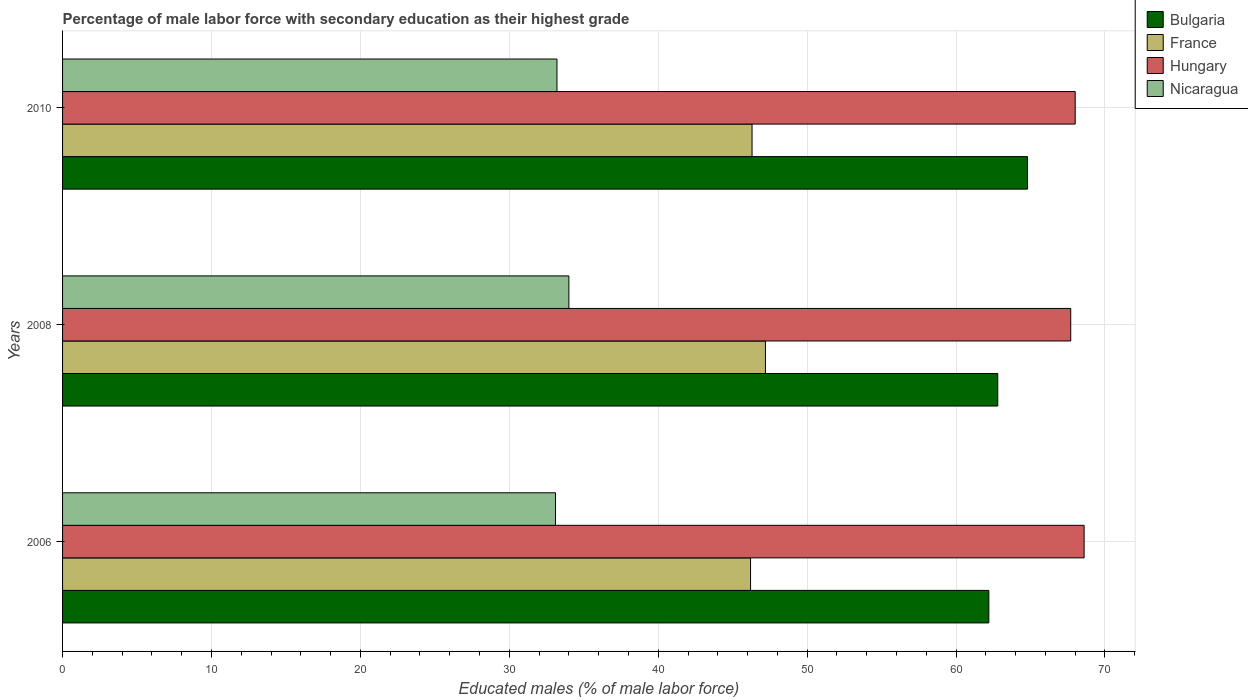Are the number of bars per tick equal to the number of legend labels?
Provide a short and direct response. Yes. Are the number of bars on each tick of the Y-axis equal?
Keep it short and to the point. Yes. How many bars are there on the 2nd tick from the bottom?
Offer a very short reply. 4. What is the percentage of male labor force with secondary education in Nicaragua in 2006?
Ensure brevity in your answer.  33.1. Across all years, what is the maximum percentage of male labor force with secondary education in Hungary?
Make the answer very short. 68.6. Across all years, what is the minimum percentage of male labor force with secondary education in France?
Your response must be concise. 46.2. In which year was the percentage of male labor force with secondary education in Hungary minimum?
Offer a terse response. 2008. What is the total percentage of male labor force with secondary education in Hungary in the graph?
Ensure brevity in your answer.  204.3. What is the difference between the percentage of male labor force with secondary education in Bulgaria in 2006 and that in 2010?
Your answer should be compact. -2.6. What is the difference between the percentage of male labor force with secondary education in France in 2006 and the percentage of male labor force with secondary education in Bulgaria in 2008?
Ensure brevity in your answer.  -16.6. What is the average percentage of male labor force with secondary education in France per year?
Your answer should be compact. 46.57. In the year 2006, what is the difference between the percentage of male labor force with secondary education in Hungary and percentage of male labor force with secondary education in Nicaragua?
Your answer should be very brief. 35.5. In how many years, is the percentage of male labor force with secondary education in Nicaragua greater than 24 %?
Provide a succinct answer. 3. What is the ratio of the percentage of male labor force with secondary education in Nicaragua in 2006 to that in 2008?
Provide a short and direct response. 0.97. Is the percentage of male labor force with secondary education in Bulgaria in 2008 less than that in 2010?
Provide a short and direct response. Yes. What is the difference between the highest and the second highest percentage of male labor force with secondary education in Nicaragua?
Keep it short and to the point. 0.8. What does the 1st bar from the top in 2008 represents?
Your answer should be very brief. Nicaragua. What does the 3rd bar from the bottom in 2006 represents?
Provide a succinct answer. Hungary. How many bars are there?
Make the answer very short. 12. Are all the bars in the graph horizontal?
Provide a short and direct response. Yes. What is the title of the graph?
Keep it short and to the point. Percentage of male labor force with secondary education as their highest grade. What is the label or title of the X-axis?
Ensure brevity in your answer.  Educated males (% of male labor force). What is the Educated males (% of male labor force) in Bulgaria in 2006?
Your answer should be compact. 62.2. What is the Educated males (% of male labor force) of France in 2006?
Your response must be concise. 46.2. What is the Educated males (% of male labor force) in Hungary in 2006?
Provide a succinct answer. 68.6. What is the Educated males (% of male labor force) of Nicaragua in 2006?
Offer a very short reply. 33.1. What is the Educated males (% of male labor force) in Bulgaria in 2008?
Your response must be concise. 62.8. What is the Educated males (% of male labor force) in France in 2008?
Offer a very short reply. 47.2. What is the Educated males (% of male labor force) of Hungary in 2008?
Your answer should be very brief. 67.7. What is the Educated males (% of male labor force) in Bulgaria in 2010?
Your answer should be compact. 64.8. What is the Educated males (% of male labor force) of France in 2010?
Your answer should be compact. 46.3. What is the Educated males (% of male labor force) in Nicaragua in 2010?
Your answer should be compact. 33.2. Across all years, what is the maximum Educated males (% of male labor force) in Bulgaria?
Offer a very short reply. 64.8. Across all years, what is the maximum Educated males (% of male labor force) of France?
Provide a succinct answer. 47.2. Across all years, what is the maximum Educated males (% of male labor force) of Hungary?
Provide a succinct answer. 68.6. Across all years, what is the minimum Educated males (% of male labor force) in Bulgaria?
Provide a short and direct response. 62.2. Across all years, what is the minimum Educated males (% of male labor force) of France?
Your answer should be compact. 46.2. Across all years, what is the minimum Educated males (% of male labor force) in Hungary?
Provide a succinct answer. 67.7. Across all years, what is the minimum Educated males (% of male labor force) in Nicaragua?
Give a very brief answer. 33.1. What is the total Educated males (% of male labor force) of Bulgaria in the graph?
Provide a succinct answer. 189.8. What is the total Educated males (% of male labor force) in France in the graph?
Your response must be concise. 139.7. What is the total Educated males (% of male labor force) in Hungary in the graph?
Keep it short and to the point. 204.3. What is the total Educated males (% of male labor force) of Nicaragua in the graph?
Keep it short and to the point. 100.3. What is the difference between the Educated males (% of male labor force) in Bulgaria in 2006 and that in 2008?
Ensure brevity in your answer.  -0.6. What is the difference between the Educated males (% of male labor force) in France in 2006 and that in 2008?
Provide a succinct answer. -1. What is the difference between the Educated males (% of male labor force) of Nicaragua in 2006 and that in 2008?
Offer a very short reply. -0.9. What is the difference between the Educated males (% of male labor force) in France in 2006 and that in 2010?
Provide a short and direct response. -0.1. What is the difference between the Educated males (% of male labor force) of Hungary in 2006 and that in 2010?
Offer a terse response. 0.6. What is the difference between the Educated males (% of male labor force) of France in 2008 and that in 2010?
Provide a succinct answer. 0.9. What is the difference between the Educated males (% of male labor force) in Hungary in 2008 and that in 2010?
Your answer should be compact. -0.3. What is the difference between the Educated males (% of male labor force) of Nicaragua in 2008 and that in 2010?
Ensure brevity in your answer.  0.8. What is the difference between the Educated males (% of male labor force) in Bulgaria in 2006 and the Educated males (% of male labor force) in France in 2008?
Provide a succinct answer. 15. What is the difference between the Educated males (% of male labor force) in Bulgaria in 2006 and the Educated males (% of male labor force) in Nicaragua in 2008?
Make the answer very short. 28.2. What is the difference between the Educated males (% of male labor force) of France in 2006 and the Educated males (% of male labor force) of Hungary in 2008?
Keep it short and to the point. -21.5. What is the difference between the Educated males (% of male labor force) of Hungary in 2006 and the Educated males (% of male labor force) of Nicaragua in 2008?
Provide a short and direct response. 34.6. What is the difference between the Educated males (% of male labor force) of France in 2006 and the Educated males (% of male labor force) of Hungary in 2010?
Your response must be concise. -21.8. What is the difference between the Educated males (% of male labor force) of France in 2006 and the Educated males (% of male labor force) of Nicaragua in 2010?
Your answer should be compact. 13. What is the difference between the Educated males (% of male labor force) in Hungary in 2006 and the Educated males (% of male labor force) in Nicaragua in 2010?
Your answer should be very brief. 35.4. What is the difference between the Educated males (% of male labor force) of Bulgaria in 2008 and the Educated males (% of male labor force) of Nicaragua in 2010?
Keep it short and to the point. 29.6. What is the difference between the Educated males (% of male labor force) of France in 2008 and the Educated males (% of male labor force) of Hungary in 2010?
Your answer should be very brief. -20.8. What is the difference between the Educated males (% of male labor force) of Hungary in 2008 and the Educated males (% of male labor force) of Nicaragua in 2010?
Provide a succinct answer. 34.5. What is the average Educated males (% of male labor force) of Bulgaria per year?
Keep it short and to the point. 63.27. What is the average Educated males (% of male labor force) in France per year?
Give a very brief answer. 46.57. What is the average Educated males (% of male labor force) of Hungary per year?
Keep it short and to the point. 68.1. What is the average Educated males (% of male labor force) in Nicaragua per year?
Make the answer very short. 33.43. In the year 2006, what is the difference between the Educated males (% of male labor force) in Bulgaria and Educated males (% of male labor force) in Nicaragua?
Your response must be concise. 29.1. In the year 2006, what is the difference between the Educated males (% of male labor force) in France and Educated males (% of male labor force) in Hungary?
Your answer should be compact. -22.4. In the year 2006, what is the difference between the Educated males (% of male labor force) in France and Educated males (% of male labor force) in Nicaragua?
Offer a terse response. 13.1. In the year 2006, what is the difference between the Educated males (% of male labor force) of Hungary and Educated males (% of male labor force) of Nicaragua?
Offer a terse response. 35.5. In the year 2008, what is the difference between the Educated males (% of male labor force) of Bulgaria and Educated males (% of male labor force) of France?
Your answer should be very brief. 15.6. In the year 2008, what is the difference between the Educated males (% of male labor force) of Bulgaria and Educated males (% of male labor force) of Nicaragua?
Your response must be concise. 28.8. In the year 2008, what is the difference between the Educated males (% of male labor force) of France and Educated males (% of male labor force) of Hungary?
Keep it short and to the point. -20.5. In the year 2008, what is the difference between the Educated males (% of male labor force) in France and Educated males (% of male labor force) in Nicaragua?
Offer a very short reply. 13.2. In the year 2008, what is the difference between the Educated males (% of male labor force) of Hungary and Educated males (% of male labor force) of Nicaragua?
Provide a short and direct response. 33.7. In the year 2010, what is the difference between the Educated males (% of male labor force) of Bulgaria and Educated males (% of male labor force) of France?
Give a very brief answer. 18.5. In the year 2010, what is the difference between the Educated males (% of male labor force) of Bulgaria and Educated males (% of male labor force) of Hungary?
Your response must be concise. -3.2. In the year 2010, what is the difference between the Educated males (% of male labor force) in Bulgaria and Educated males (% of male labor force) in Nicaragua?
Keep it short and to the point. 31.6. In the year 2010, what is the difference between the Educated males (% of male labor force) in France and Educated males (% of male labor force) in Hungary?
Your response must be concise. -21.7. In the year 2010, what is the difference between the Educated males (% of male labor force) in France and Educated males (% of male labor force) in Nicaragua?
Offer a terse response. 13.1. In the year 2010, what is the difference between the Educated males (% of male labor force) of Hungary and Educated males (% of male labor force) of Nicaragua?
Make the answer very short. 34.8. What is the ratio of the Educated males (% of male labor force) in France in 2006 to that in 2008?
Your answer should be compact. 0.98. What is the ratio of the Educated males (% of male labor force) in Hungary in 2006 to that in 2008?
Your answer should be compact. 1.01. What is the ratio of the Educated males (% of male labor force) of Nicaragua in 2006 to that in 2008?
Give a very brief answer. 0.97. What is the ratio of the Educated males (% of male labor force) of Bulgaria in 2006 to that in 2010?
Keep it short and to the point. 0.96. What is the ratio of the Educated males (% of male labor force) of France in 2006 to that in 2010?
Offer a very short reply. 1. What is the ratio of the Educated males (% of male labor force) of Hungary in 2006 to that in 2010?
Give a very brief answer. 1.01. What is the ratio of the Educated males (% of male labor force) in Bulgaria in 2008 to that in 2010?
Offer a very short reply. 0.97. What is the ratio of the Educated males (% of male labor force) in France in 2008 to that in 2010?
Ensure brevity in your answer.  1.02. What is the ratio of the Educated males (% of male labor force) of Hungary in 2008 to that in 2010?
Your answer should be compact. 1. What is the ratio of the Educated males (% of male labor force) in Nicaragua in 2008 to that in 2010?
Offer a terse response. 1.02. What is the difference between the highest and the lowest Educated males (% of male labor force) of Bulgaria?
Keep it short and to the point. 2.6. What is the difference between the highest and the lowest Educated males (% of male labor force) of France?
Make the answer very short. 1. What is the difference between the highest and the lowest Educated males (% of male labor force) in Nicaragua?
Offer a very short reply. 0.9. 